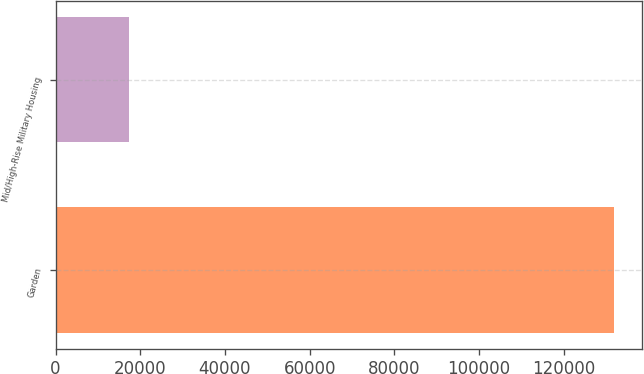Convert chart. <chart><loc_0><loc_0><loc_500><loc_500><bar_chart><fcel>Garden<fcel>Mid/High-Rise Military Housing<nl><fcel>131865<fcel>17225<nl></chart> 